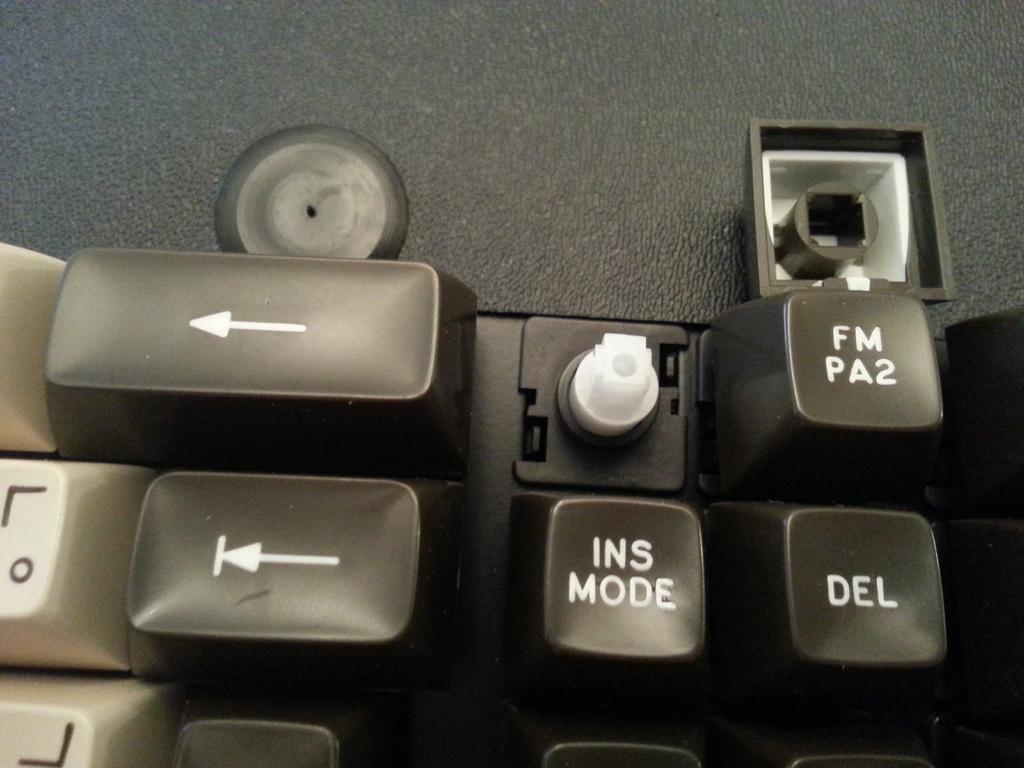What is the key below the broken key?
Your answer should be compact. Ins mode. 